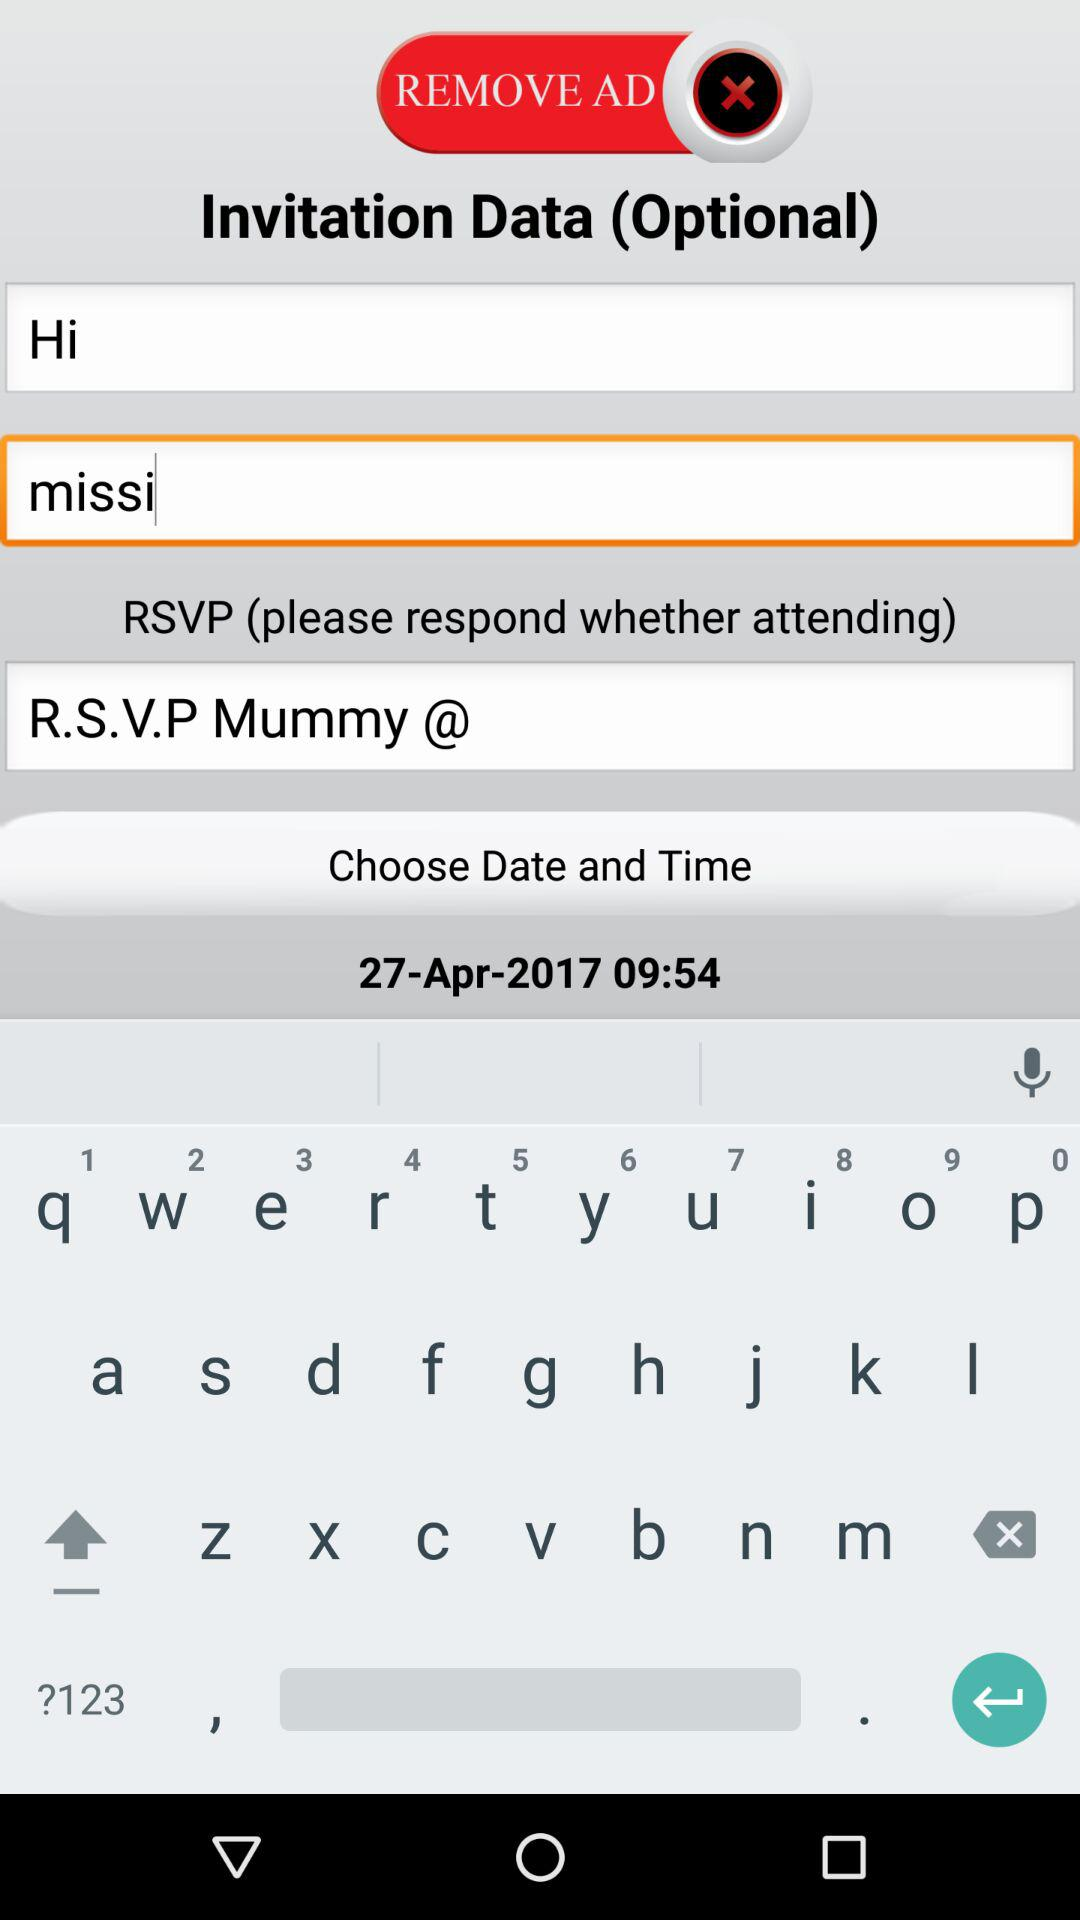What was the chosen date? The chosen date was April 27, 2017. 